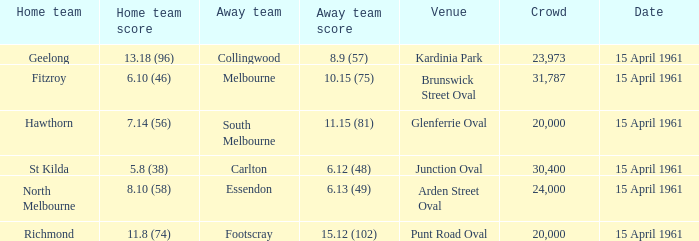Which venue had a home team score of 6.10 (46)? Brunswick Street Oval. 